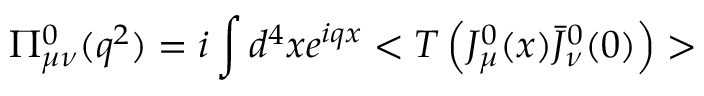Convert formula to latex. <formula><loc_0><loc_0><loc_500><loc_500>\Pi _ { \mu \nu } ^ { 0 } ( q ^ { 2 } ) = i \int d ^ { 4 } x e ^ { i q x } < T \left ( J _ { \mu } ^ { 0 } ( x ) \bar { J } _ { \nu } ^ { 0 } ( 0 ) \right ) ></formula> 